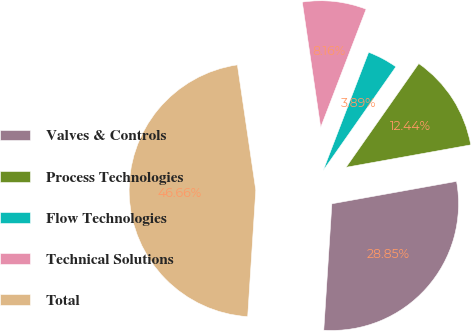Convert chart. <chart><loc_0><loc_0><loc_500><loc_500><pie_chart><fcel>Valves & Controls<fcel>Process Technologies<fcel>Flow Technologies<fcel>Technical Solutions<fcel>Total<nl><fcel>28.85%<fcel>12.44%<fcel>3.89%<fcel>8.16%<fcel>46.66%<nl></chart> 